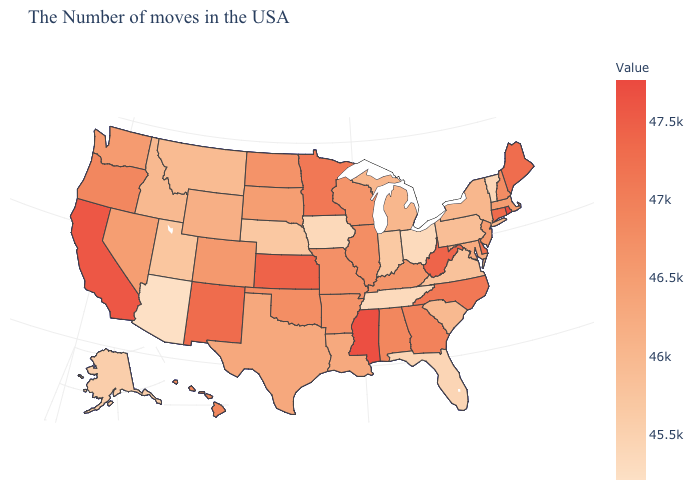Which states have the highest value in the USA?
Concise answer only. Rhode Island. Among the states that border Oklahoma , which have the lowest value?
Give a very brief answer. Texas. Does Missouri have a lower value than Wyoming?
Quick response, please. No. Which states have the lowest value in the USA?
Write a very short answer. Arizona. 